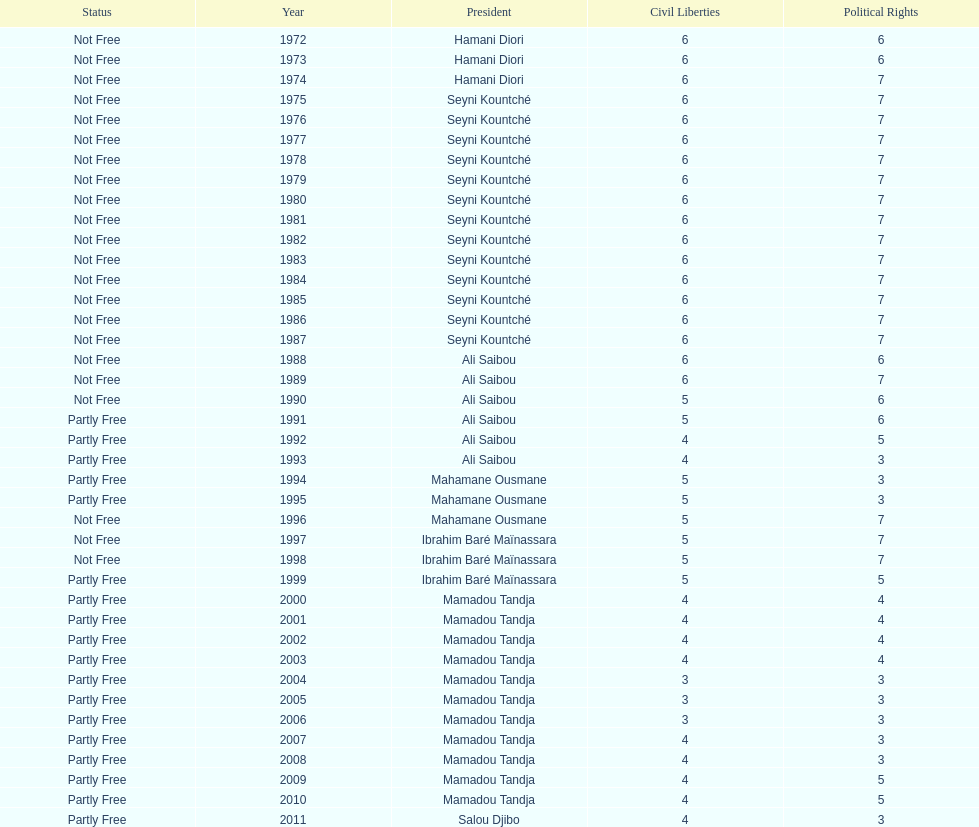What is the number of time seyni kountche has been president? 13. I'm looking to parse the entire table for insights. Could you assist me with that? {'header': ['Status', 'Year', 'President', 'Civil Liberties', 'Political Rights'], 'rows': [['Not Free', '1972', 'Hamani Diori', '6', '6'], ['Not Free', '1973', 'Hamani Diori', '6', '6'], ['Not Free', '1974', 'Hamani Diori', '6', '7'], ['Not Free', '1975', 'Seyni Kountché', '6', '7'], ['Not Free', '1976', 'Seyni Kountché', '6', '7'], ['Not Free', '1977', 'Seyni Kountché', '6', '7'], ['Not Free', '1978', 'Seyni Kountché', '6', '7'], ['Not Free', '1979', 'Seyni Kountché', '6', '7'], ['Not Free', '1980', 'Seyni Kountché', '6', '7'], ['Not Free', '1981', 'Seyni Kountché', '6', '7'], ['Not Free', '1982', 'Seyni Kountché', '6', '7'], ['Not Free', '1983', 'Seyni Kountché', '6', '7'], ['Not Free', '1984', 'Seyni Kountché', '6', '7'], ['Not Free', '1985', 'Seyni Kountché', '6', '7'], ['Not Free', '1986', 'Seyni Kountché', '6', '7'], ['Not Free', '1987', 'Seyni Kountché', '6', '7'], ['Not Free', '1988', 'Ali Saibou', '6', '6'], ['Not Free', '1989', 'Ali Saibou', '6', '7'], ['Not Free', '1990', 'Ali Saibou', '5', '6'], ['Partly Free', '1991', 'Ali Saibou', '5', '6'], ['Partly Free', '1992', 'Ali Saibou', '4', '5'], ['Partly Free', '1993', 'Ali Saibou', '4', '3'], ['Partly Free', '1994', 'Mahamane Ousmane', '5', '3'], ['Partly Free', '1995', 'Mahamane Ousmane', '5', '3'], ['Not Free', '1996', 'Mahamane Ousmane', '5', '7'], ['Not Free', '1997', 'Ibrahim Baré Maïnassara', '5', '7'], ['Not Free', '1998', 'Ibrahim Baré Maïnassara', '5', '7'], ['Partly Free', '1999', 'Ibrahim Baré Maïnassara', '5', '5'], ['Partly Free', '2000', 'Mamadou Tandja', '4', '4'], ['Partly Free', '2001', 'Mamadou Tandja', '4', '4'], ['Partly Free', '2002', 'Mamadou Tandja', '4', '4'], ['Partly Free', '2003', 'Mamadou Tandja', '4', '4'], ['Partly Free', '2004', 'Mamadou Tandja', '3', '3'], ['Partly Free', '2005', 'Mamadou Tandja', '3', '3'], ['Partly Free', '2006', 'Mamadou Tandja', '3', '3'], ['Partly Free', '2007', 'Mamadou Tandja', '4', '3'], ['Partly Free', '2008', 'Mamadou Tandja', '4', '3'], ['Partly Free', '2009', 'Mamadou Tandja', '4', '5'], ['Partly Free', '2010', 'Mamadou Tandja', '4', '5'], ['Partly Free', '2011', 'Salou Djibo', '4', '3']]} 